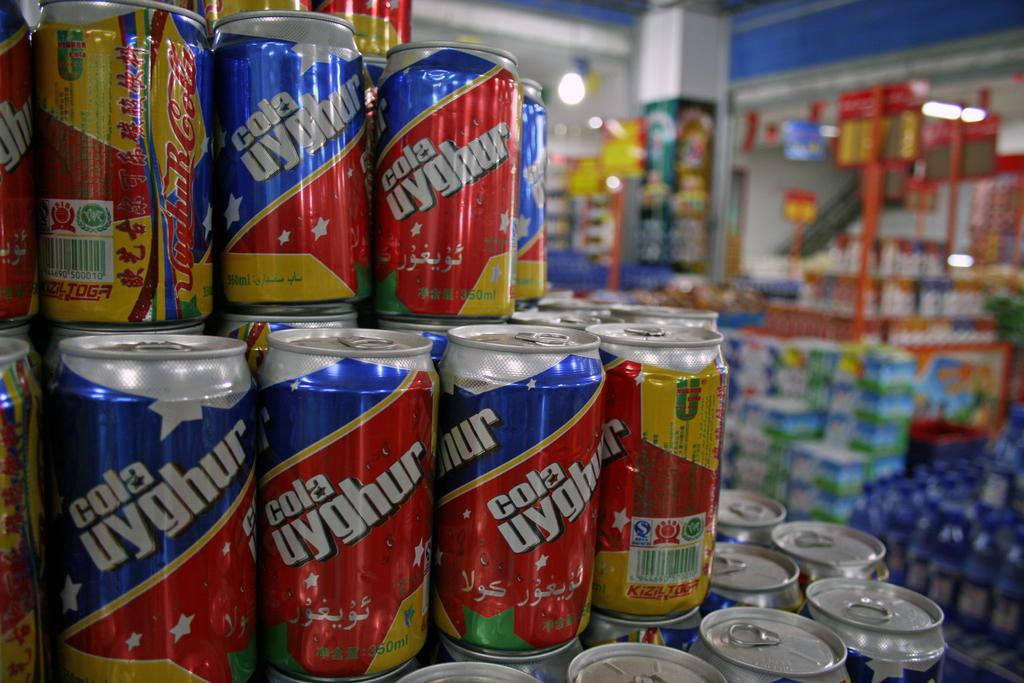<image>
Give a short and clear explanation of the subsequent image. A display of cans of cola uyghur stacked in a pyramid of sorts. 